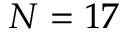<formula> <loc_0><loc_0><loc_500><loc_500>N = 1 7</formula> 